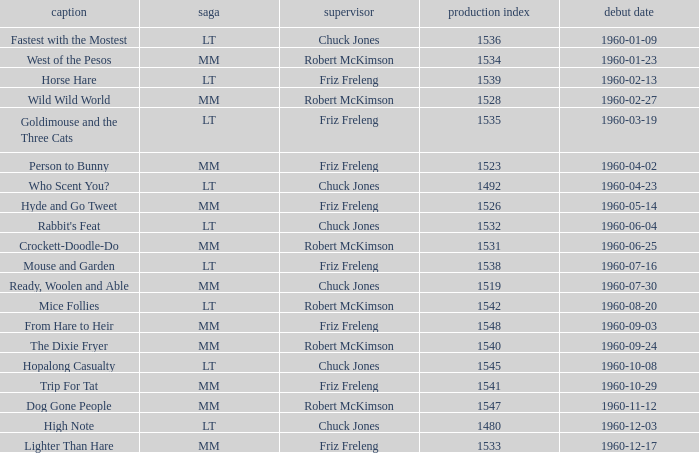What is the production number for the episode directed by Robert McKimson named Mice Follies? 1.0. 